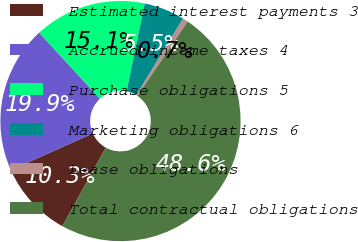<chart> <loc_0><loc_0><loc_500><loc_500><pie_chart><fcel>Estimated interest payments 3<fcel>Accrued income taxes 4<fcel>Purchase obligations 5<fcel>Marketing obligations 6<fcel>Lease obligations<fcel>Total contractual obligations<nl><fcel>10.28%<fcel>19.86%<fcel>15.07%<fcel>5.49%<fcel>0.71%<fcel>48.59%<nl></chart> 